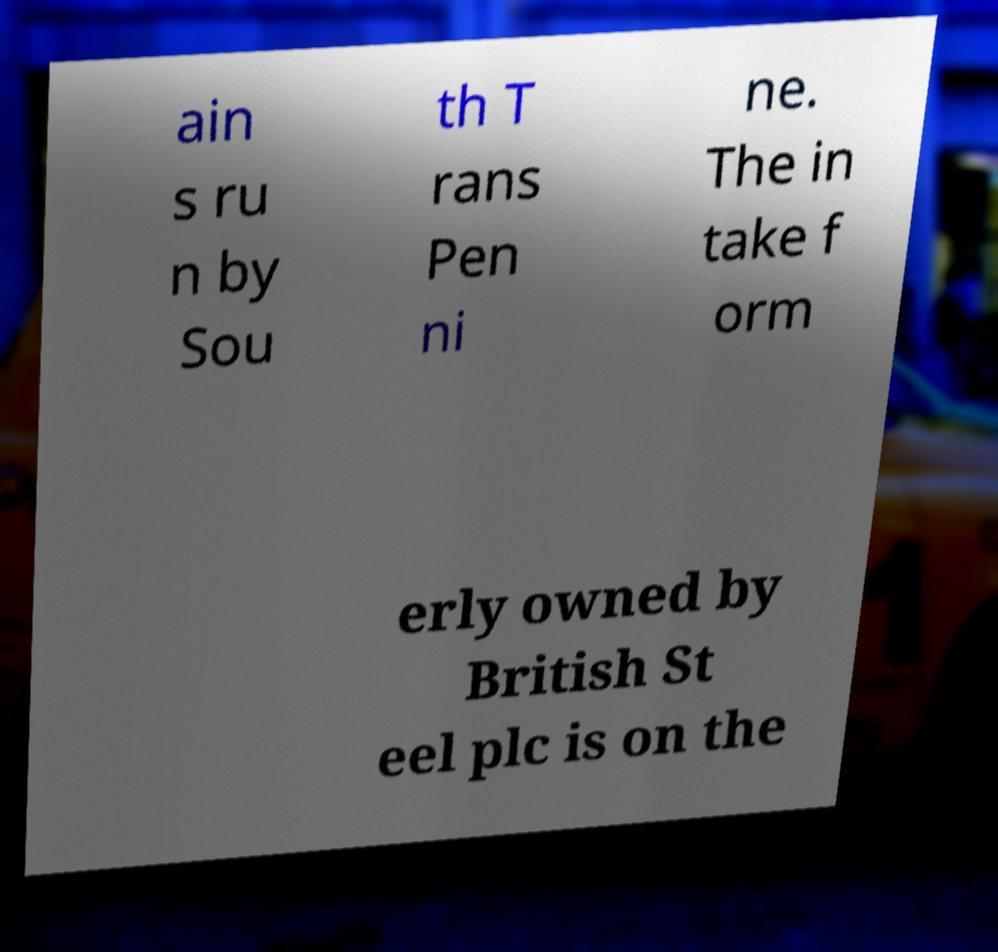There's text embedded in this image that I need extracted. Can you transcribe it verbatim? ain s ru n by Sou th T rans Pen ni ne. The in take f orm erly owned by British St eel plc is on the 